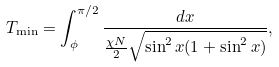Convert formula to latex. <formula><loc_0><loc_0><loc_500><loc_500>T _ { \min } = \int _ { \phi } ^ { \pi / 2 } \frac { d x } { \frac { \chi N } { 2 } \sqrt { \sin ^ { 2 } x ( 1 + \sin ^ { 2 } x ) } } ,</formula> 